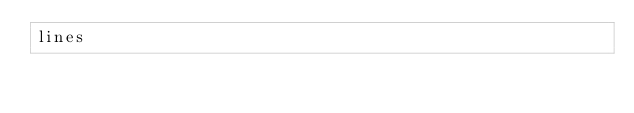Convert code to text. <code><loc_0><loc_0><loc_500><loc_500><_Perl_>lines</code> 